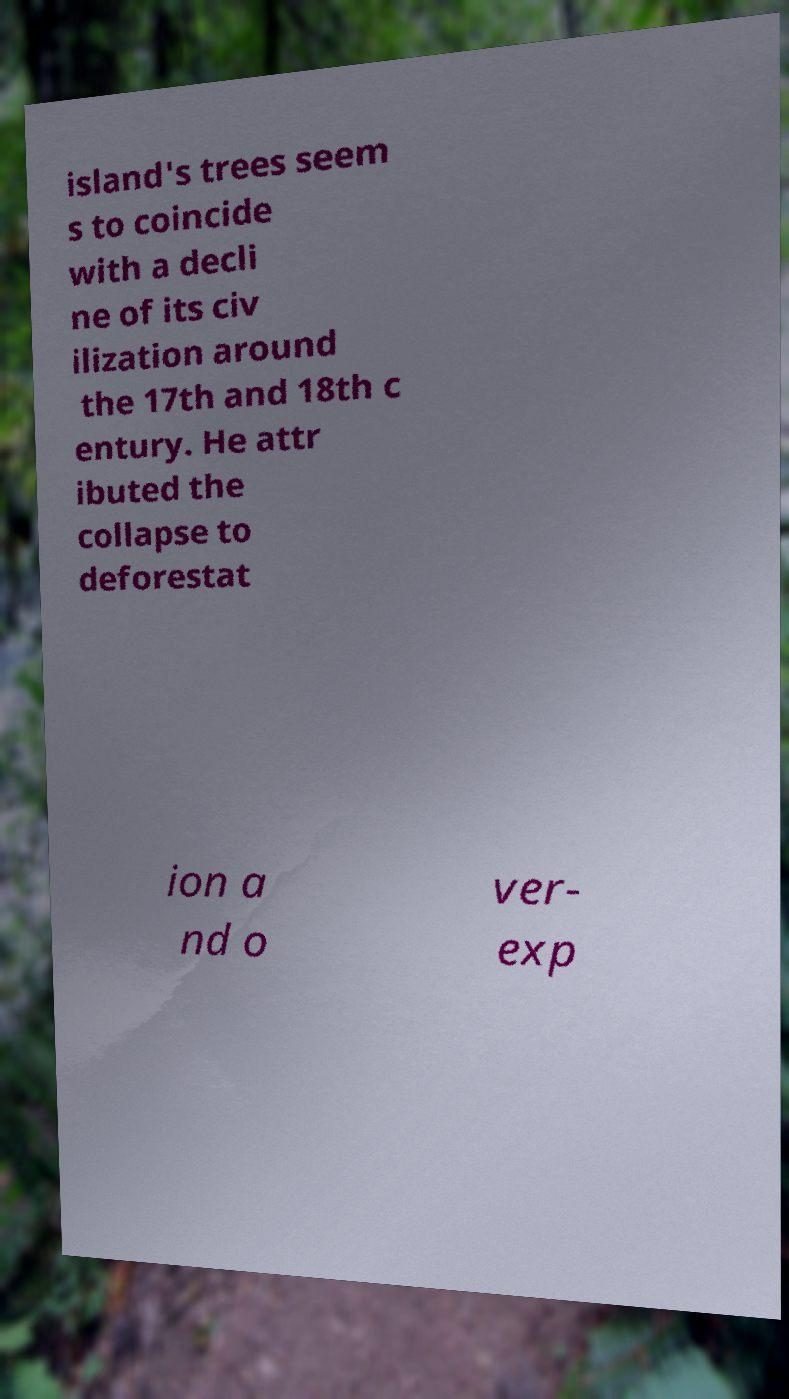Could you assist in decoding the text presented in this image and type it out clearly? island's trees seem s to coincide with a decli ne of its civ ilization around the 17th and 18th c entury. He attr ibuted the collapse to deforestat ion a nd o ver- exp 